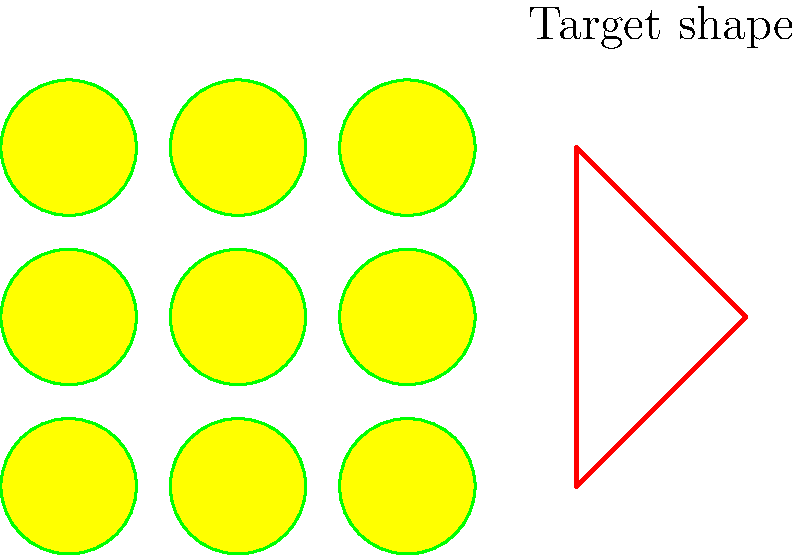In this visual puzzle, you need to arrange tennis balls to form a specific shape. Given a 3x3 grid of tennis balls and the target shape shown in red, how many tennis balls must be removed to create the target shape? Let's approach this step-by-step:

1. First, observe the 3x3 grid of tennis balls. There are 9 balls in total.

2. Now, look at the target shape. It's an equilateral triangle pointing upwards.

3. To form this shape with the tennis balls:
   - We need 3 balls at the base (bottom row)
   - 2 balls in the middle row
   - 1 ball at the top

4. Count the balls needed for the target shape:
   $3 + 2 + 1 = 6$ balls

5. Calculate the number of balls to remove:
   - Total balls: 9
   - Balls needed for the shape: 6
   - Balls to remove: $9 - 6 = 3$

Therefore, 3 tennis balls must be removed to create the target shape.
Answer: 3 